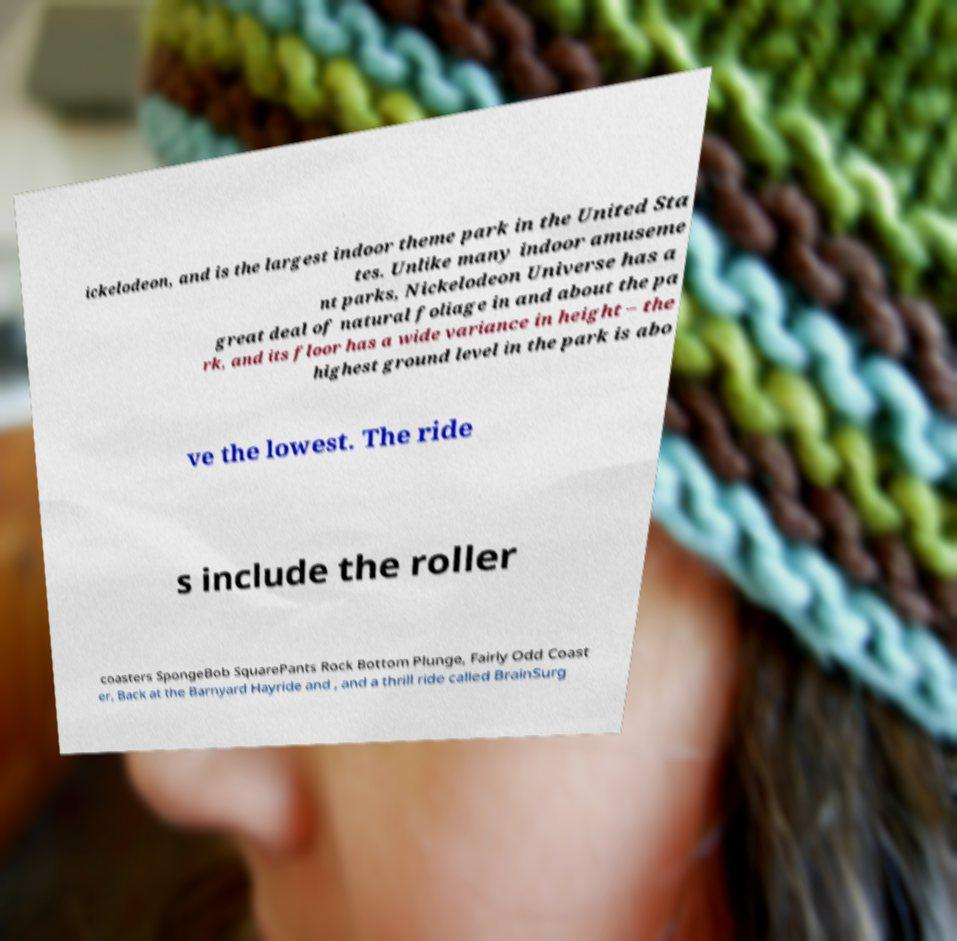For documentation purposes, I need the text within this image transcribed. Could you provide that? ickelodeon, and is the largest indoor theme park in the United Sta tes. Unlike many indoor amuseme nt parks, Nickelodeon Universe has a great deal of natural foliage in and about the pa rk, and its floor has a wide variance in height – the highest ground level in the park is abo ve the lowest. The ride s include the roller coasters SpongeBob SquarePants Rock Bottom Plunge, Fairly Odd Coast er, Back at the Barnyard Hayride and , and a thrill ride called BrainSurg 